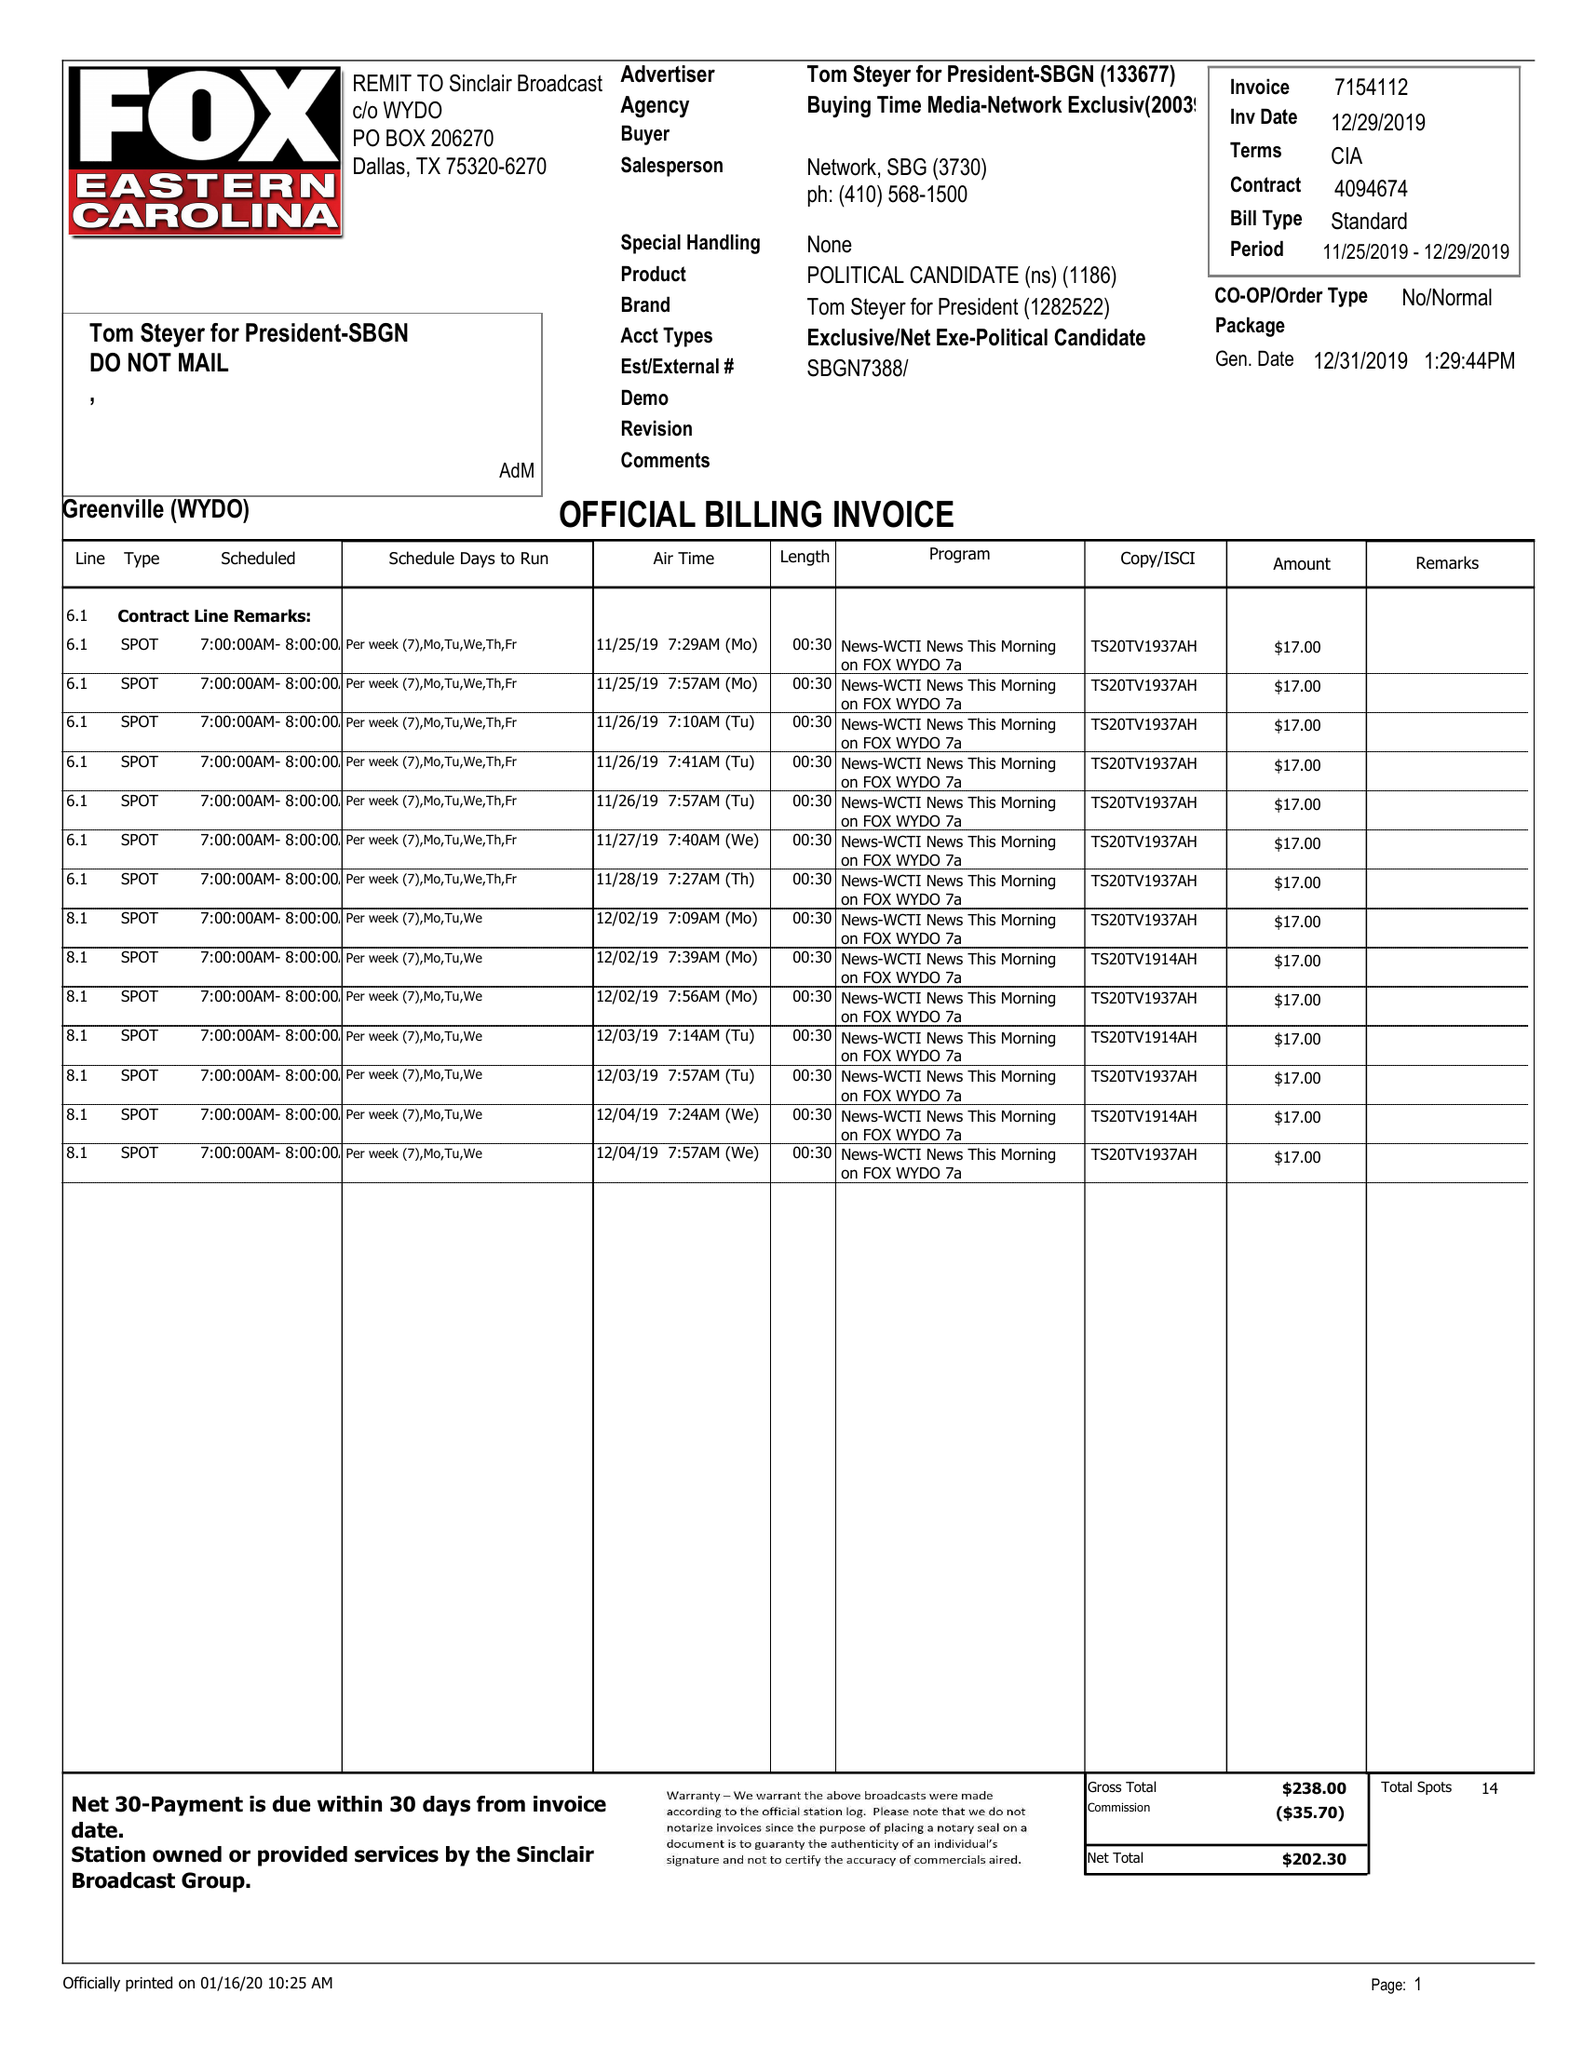What is the value for the advertiser?
Answer the question using a single word or phrase. TOM STEYER FOR PRESIDENT-SBGN 